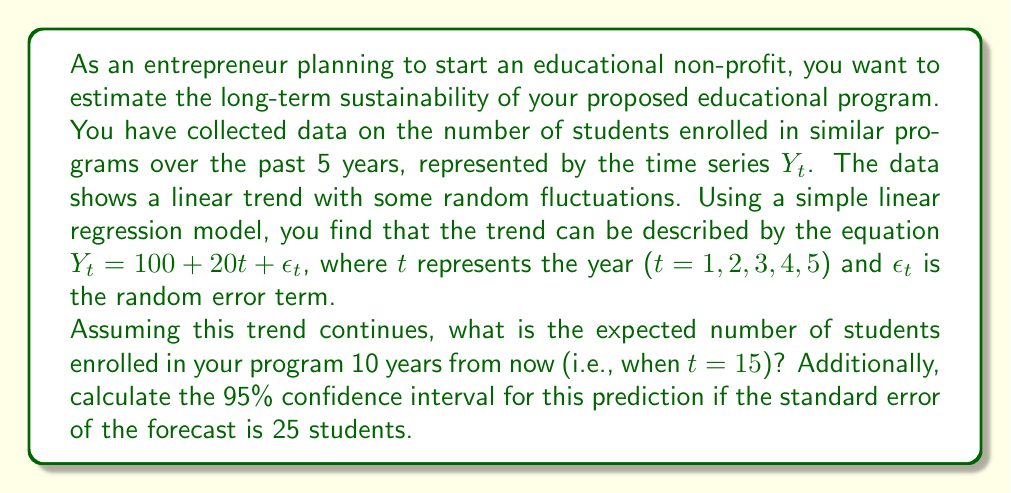Give your solution to this math problem. To solve this problem, we'll follow these steps:

1. Identify the linear trend model:
   The model is given by $Y_t = 100 + 20t + \epsilon_t$

2. Calculate the point forecast for t = 15:
   $\hat{Y}_{15} = 100 + 20(15) = 100 + 300 = 400$

3. Calculate the confidence interval:
   For a 95% confidence interval, we use the z-score of 1.96 (assuming normal distribution).
   The formula for the confidence interval is:
   $\text{CI} = \hat{Y}_t \pm z \cdot SE$
   where $SE$ is the standard error of the forecast, given as 25 students.

   Lower bound: $400 - 1.96 \cdot 25 = 400 - 49 = 351$
   Upper bound: $400 + 1.96 \cdot 25 = 400 + 49 = 449$

Therefore, the point forecast for the number of students 10 years from now is 400, with a 95% confidence interval of (351, 449) students.

This analysis suggests that your educational program is likely to grow steadily over time, which indicates potential long-term sustainability. However, it's important to note that this simple model assumes the linear trend will continue indefinitely, which may not always be the case in real-world scenarios. Factors such as market saturation, competition, or changes in educational policies could affect the actual growth rate.
Answer: 400 students; 95% CI: (351, 449) 